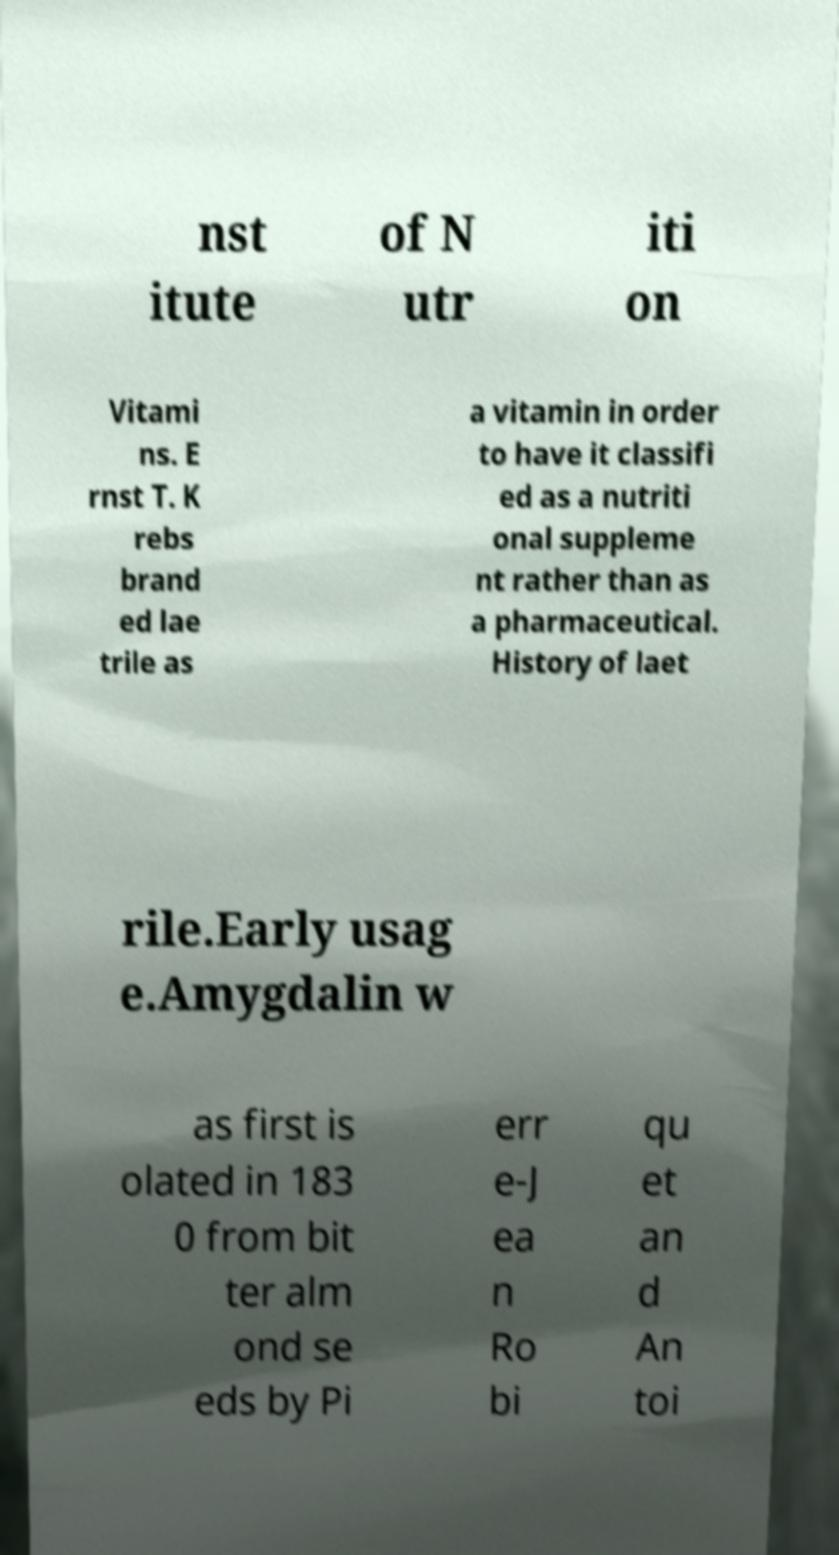Please identify and transcribe the text found in this image. nst itute of N utr iti on Vitami ns. E rnst T. K rebs brand ed lae trile as a vitamin in order to have it classifi ed as a nutriti onal suppleme nt rather than as a pharmaceutical. History of laet rile.Early usag e.Amygdalin w as first is olated in 183 0 from bit ter alm ond se eds by Pi err e-J ea n Ro bi qu et an d An toi 